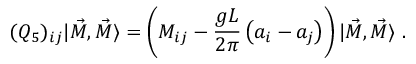Convert formula to latex. <formula><loc_0><loc_0><loc_500><loc_500>( Q _ { 5 } ) _ { i j } | \vec { M } , \vec { M } \rangle = \left ( M _ { i j } - \frac { g L } { 2 \pi } \left ( a _ { i } - a _ { j } \right ) \right ) | \vec { M } , \vec { M } \rangle \ .</formula> 